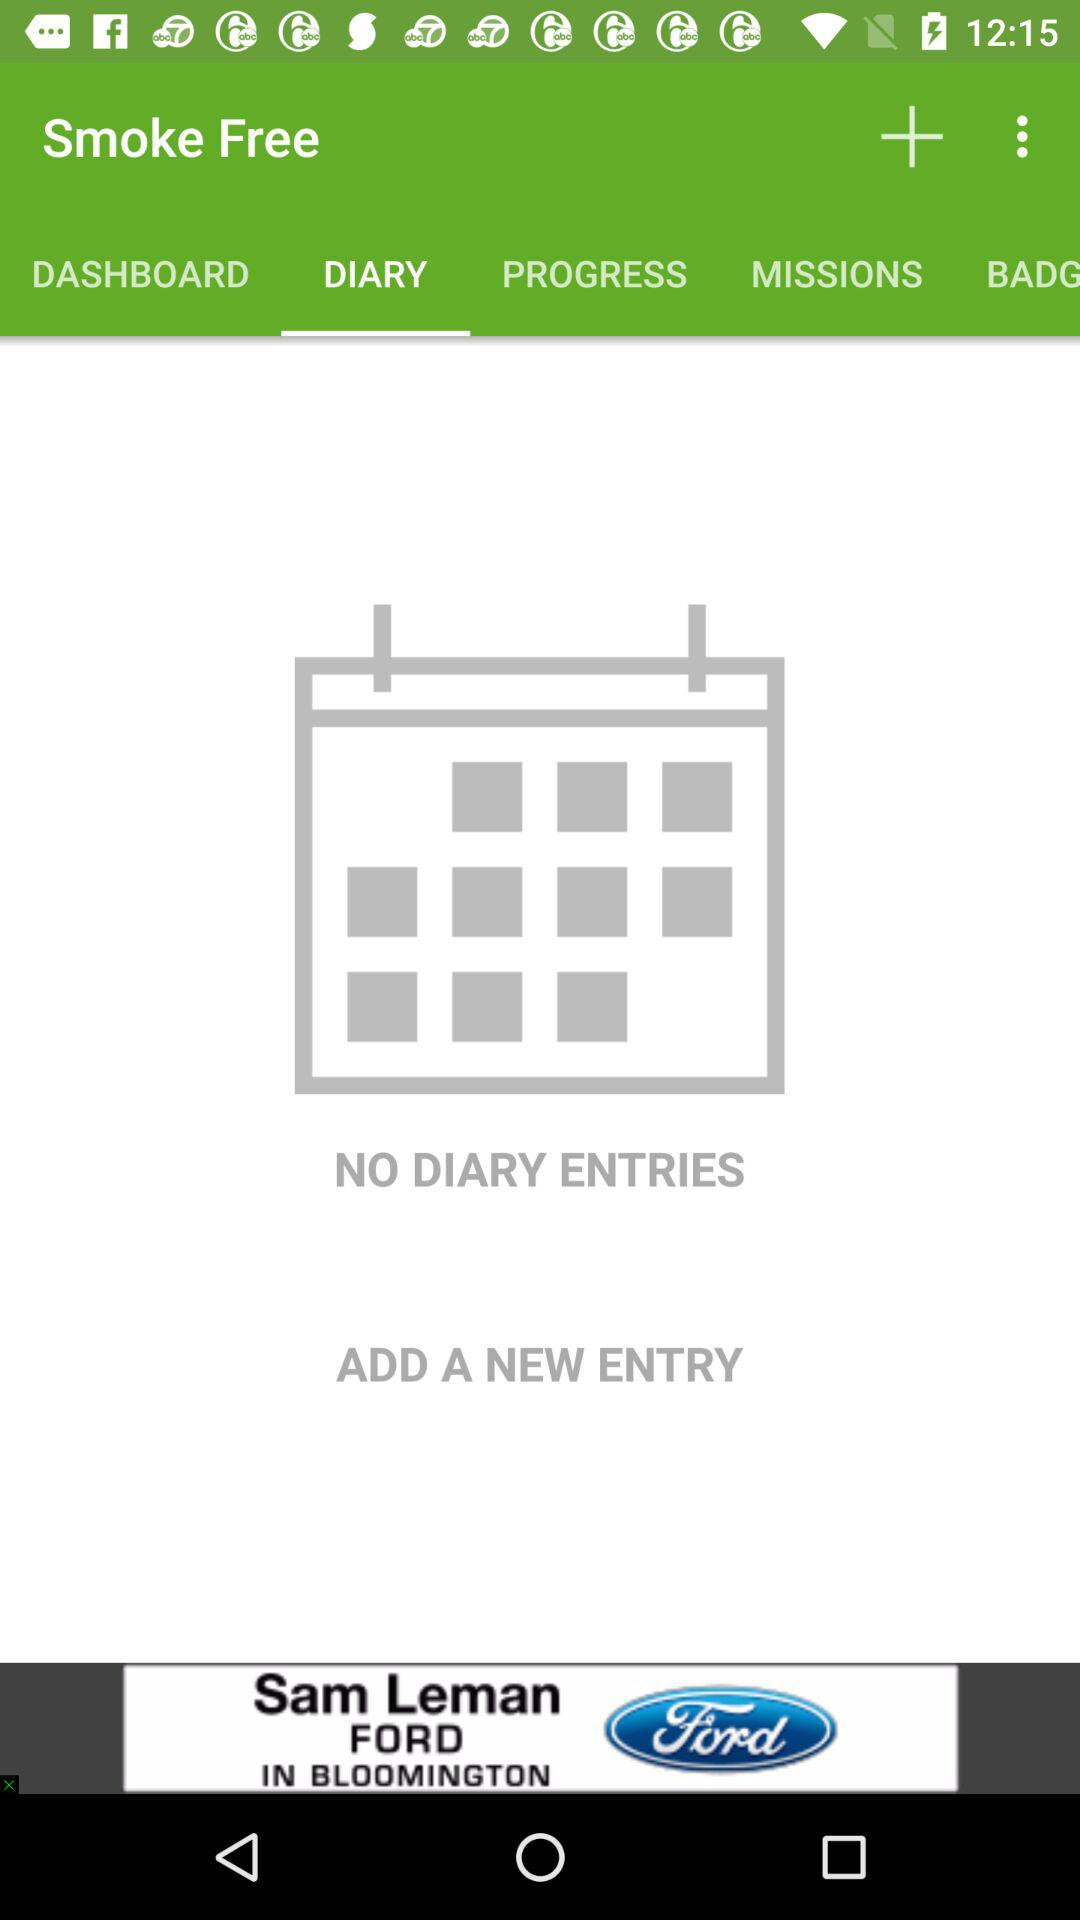How many diary entries are there?
Answer the question using a single word or phrase. 0 